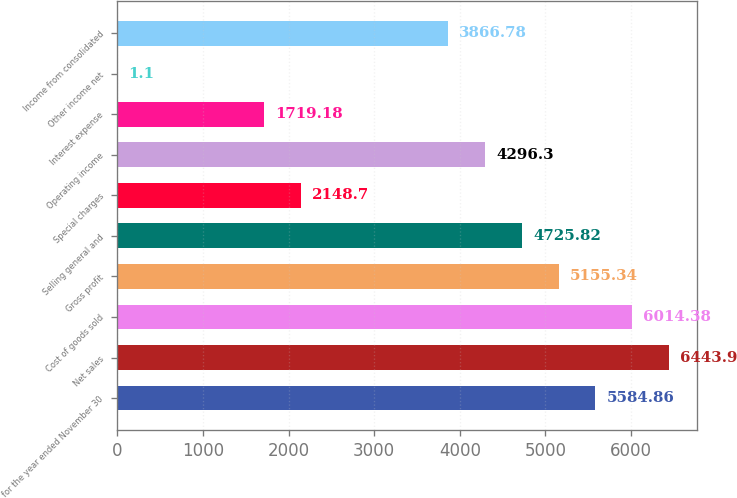Convert chart to OTSL. <chart><loc_0><loc_0><loc_500><loc_500><bar_chart><fcel>for the year ended November 30<fcel>Net sales<fcel>Cost of goods sold<fcel>Gross profit<fcel>Selling general and<fcel>Special charges<fcel>Operating income<fcel>Interest expense<fcel>Other income net<fcel>Income from consolidated<nl><fcel>5584.86<fcel>6443.9<fcel>6014.38<fcel>5155.34<fcel>4725.82<fcel>2148.7<fcel>4296.3<fcel>1719.18<fcel>1.1<fcel>3866.78<nl></chart> 